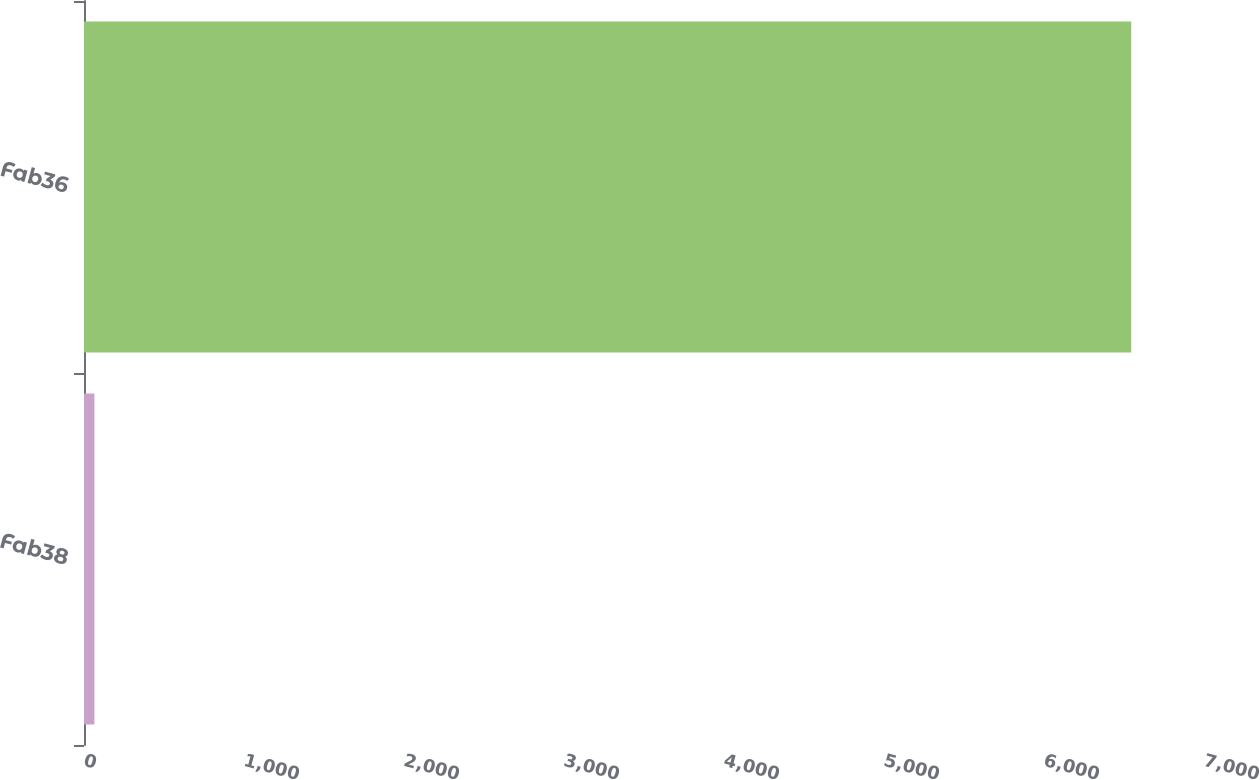Convert chart. <chart><loc_0><loc_0><loc_500><loc_500><bar_chart><fcel>Fab38<fcel>Fab36<nl><fcel>65<fcel>6545<nl></chart> 